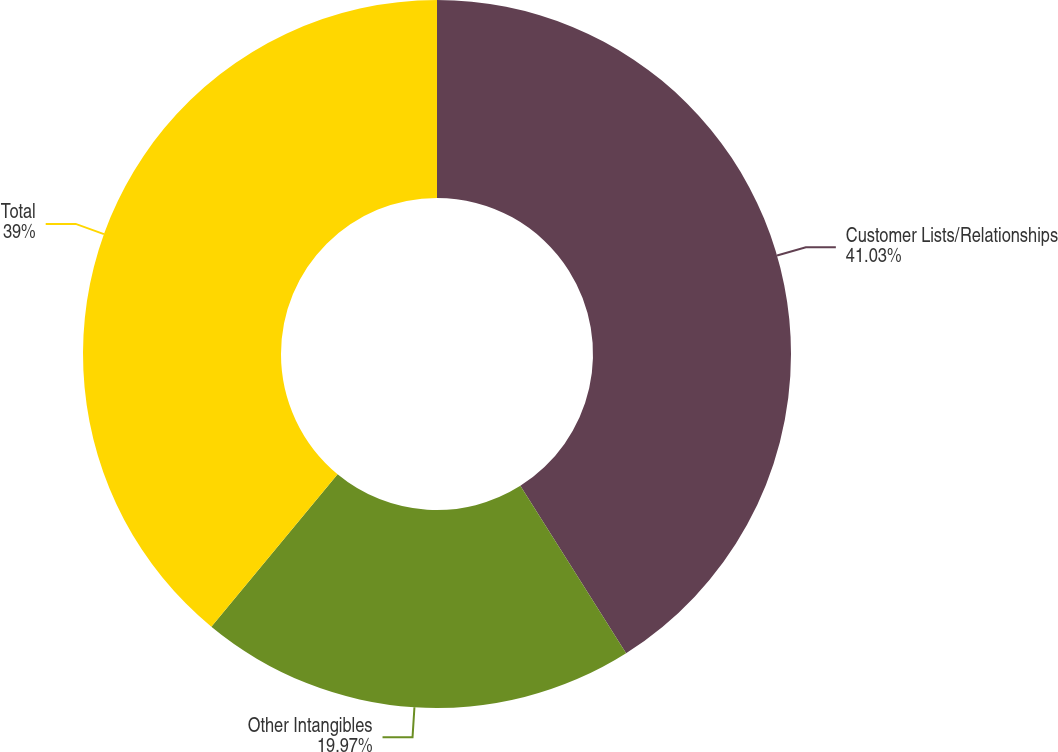<chart> <loc_0><loc_0><loc_500><loc_500><pie_chart><fcel>Customer Lists/Relationships<fcel>Other Intangibles<fcel>Total<nl><fcel>41.03%<fcel>19.97%<fcel>39.0%<nl></chart> 